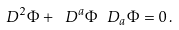Convert formula to latex. <formula><loc_0><loc_0><loc_500><loc_500>\ D ^ { 2 } \Phi + \ D ^ { a } \Phi \ D _ { a } \Phi = 0 \, .</formula> 